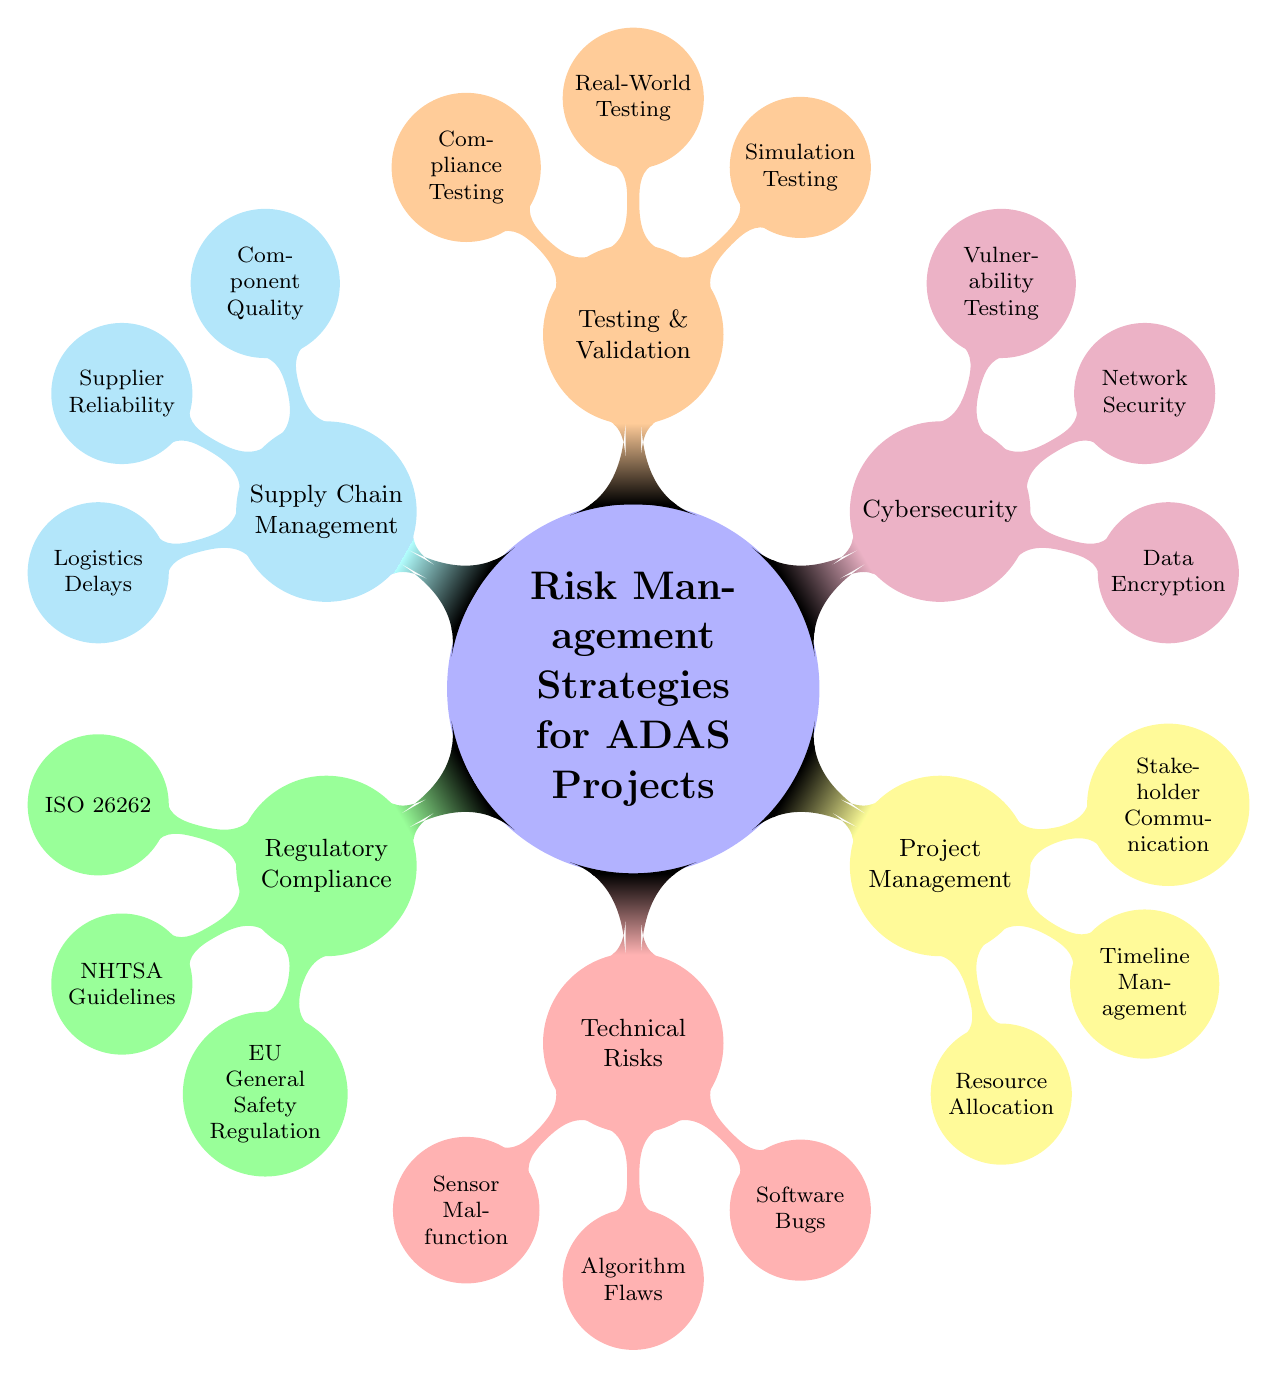What is the central node of the diagram? The central node is labeled "Risk Management Strategies for ADAS Projects," which serves as the starting point for the mind map.
Answer: Risk Management Strategies for ADAS Projects How many sub-nodes are there in total? There are six primary sub-nodes branching directly from the central node, each representing a different category of risks or strategies.
Answer: 6 Which sub-node has the focus on compliance with standards? The sub-node that addresses compliance with standards is "Regulatory Compliance," as it includes well-known automotive safety standards.
Answer: Regulatory Compliance What are the key areas under Technical Risks? The key areas listed under "Technical Risks" are "Sensor Malfunction," "Algorithm Flaws," and "Software Bugs," indicating the potential technical challenges.
Answer: Sensor Malfunction, Algorithm Flaws, Software Bugs What aspect does the "Project Management" node cover? The "Project Management" node covers several aspects, specifically "Resource Allocation," "Timeline Management," and "Stakeholder Communication," essential for managing the overall project effectively.
Answer: Resource Allocation, Timeline Management, Stakeholder Communication Which node relates to security measures? The node that relates specifically to security measures is "Cybersecurity," focusing on the protection of the system's data and network.
Answer: Cybersecurity What type of testing is included under the "Testing & Validation" node? The "Testing & Validation" node includes "Simulation Testing," "Real-World Testing," and "Compliance Testing," showing the various methods to ensure the system's effectiveness and conformity.
Answer: Simulation Testing, Real-World Testing, Compliance Testing Which sub-node addresses the quality of components? The sub-node that addresses the quality of components is "Supply Chain Management," which includes "Component Quality" as one of its focus areas to mitigate supply risks.
Answer: Supply Chain Management What is the relationship between Cybersecurity and Data Encryption? "Data Encryption" is a sub-node under "Cybersecurity," indicating that it is one of the strategies utilized within this broader risk management area.
Answer: Data Encryption 